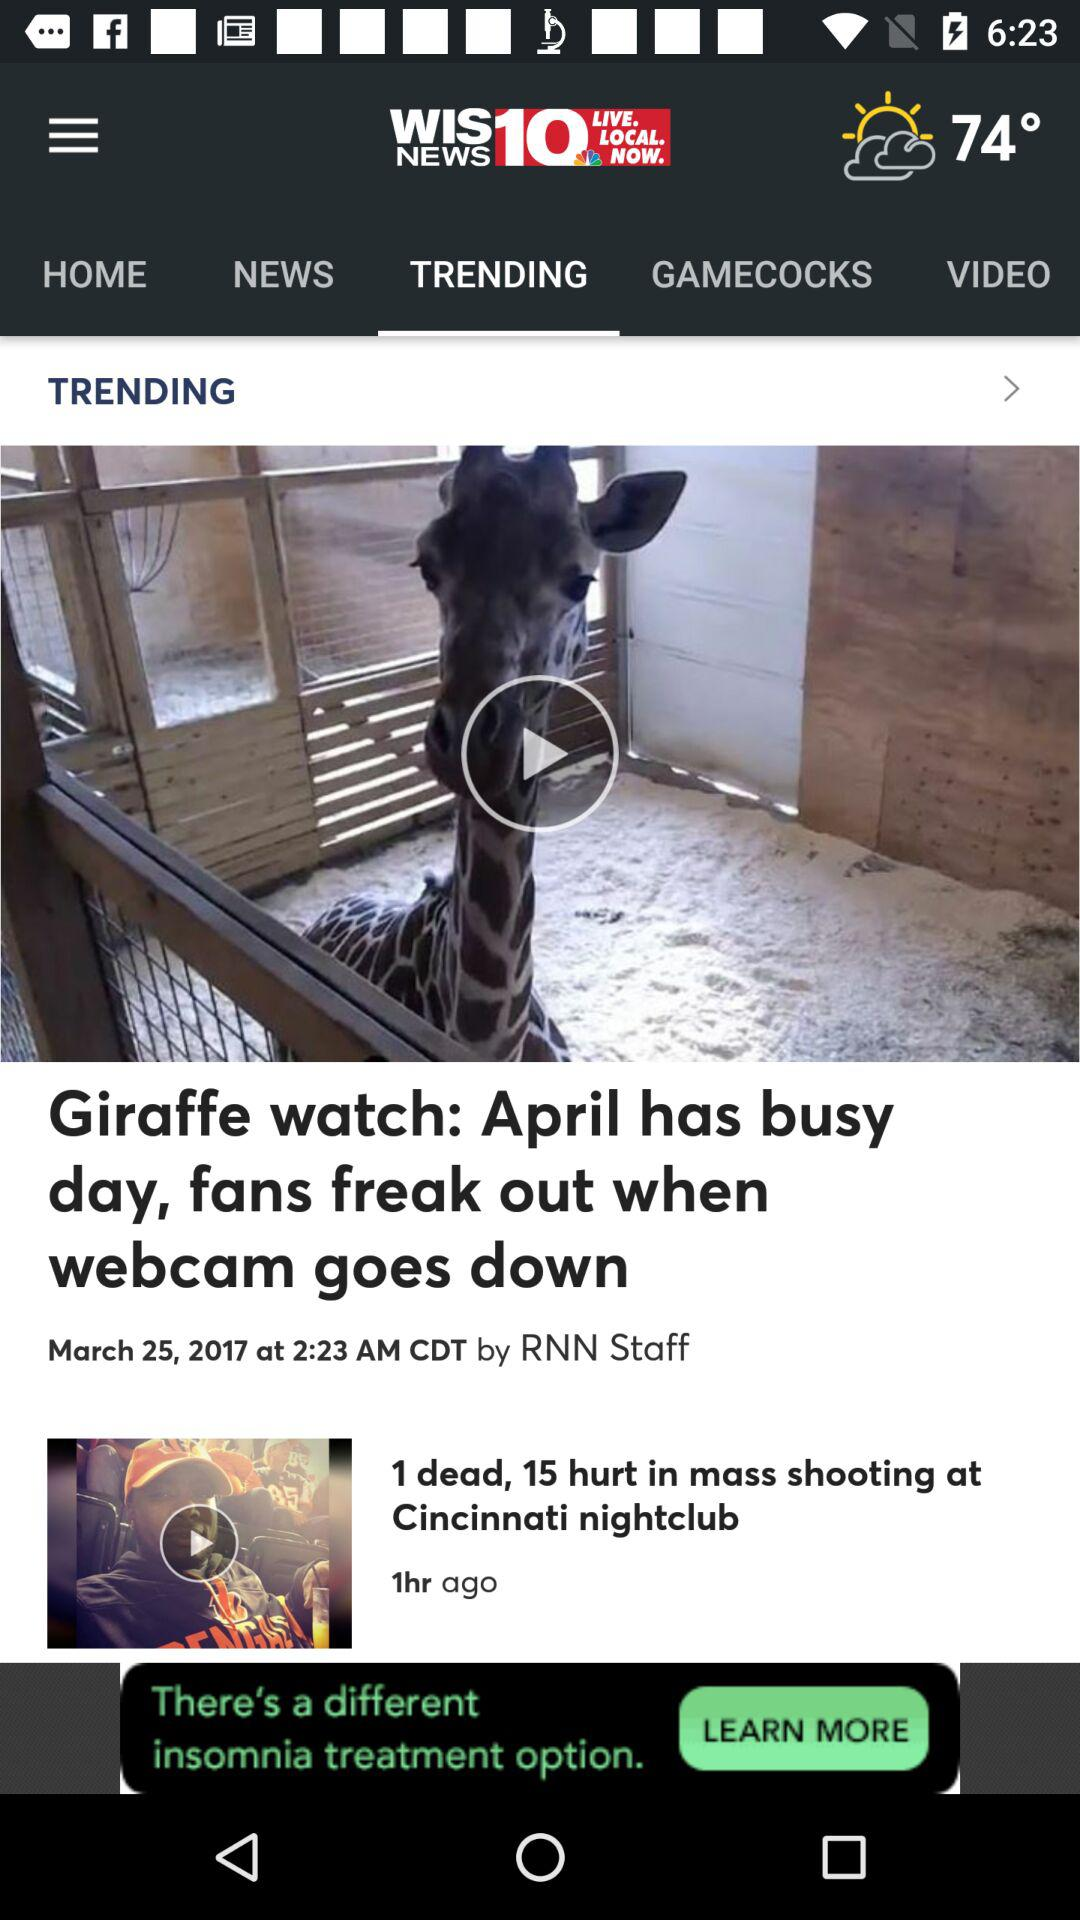How many people are hurt in mass shooting? There are 15 people hurt in the mass shooting. 